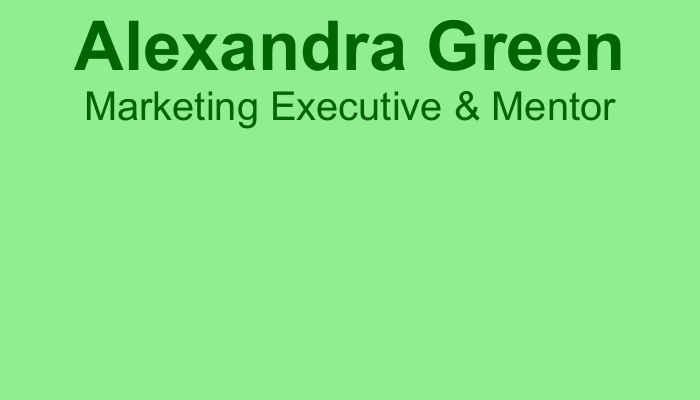What is the name on the business card? The name is prominently displayed at the top of the card.
Answer: Alexandra Green What is Alexandra's profession? The card states her profession directly following her name.
Answer: Marketing Executive & Mentor What is the email address listed? The email address is provided in the contact information section of the card.
Answer: alexandra.green@mentorshipgrowth.com What quote is included on the business card? The quote is highlighted towards the bottom of the card and attributed to a well-known individual.
Answer: "The only way to do great work is to love what you do." - Steve Jobs What are the four key values emphasized on the card? The values are listed in a small font towards the bottom of the card.
Answer: Authenticity, Hard Work, Personal Growth, Empowerment What is the phone number provided? The phone number is part of the contact information section on the card.
Answer: +1-234-567-8901 What is the link to Alexandra's website? The website link is found among the contact details of the card.
Answer: www.mentorwithalexandra.com What color is the background of the card? The background color is specified in the document's setup and is visible on the card.
Answer: Light Green What does the QR code link to? The QR code is situated on the card and links to additional information.
Answer: https://www.mentorwithalexandra.com 